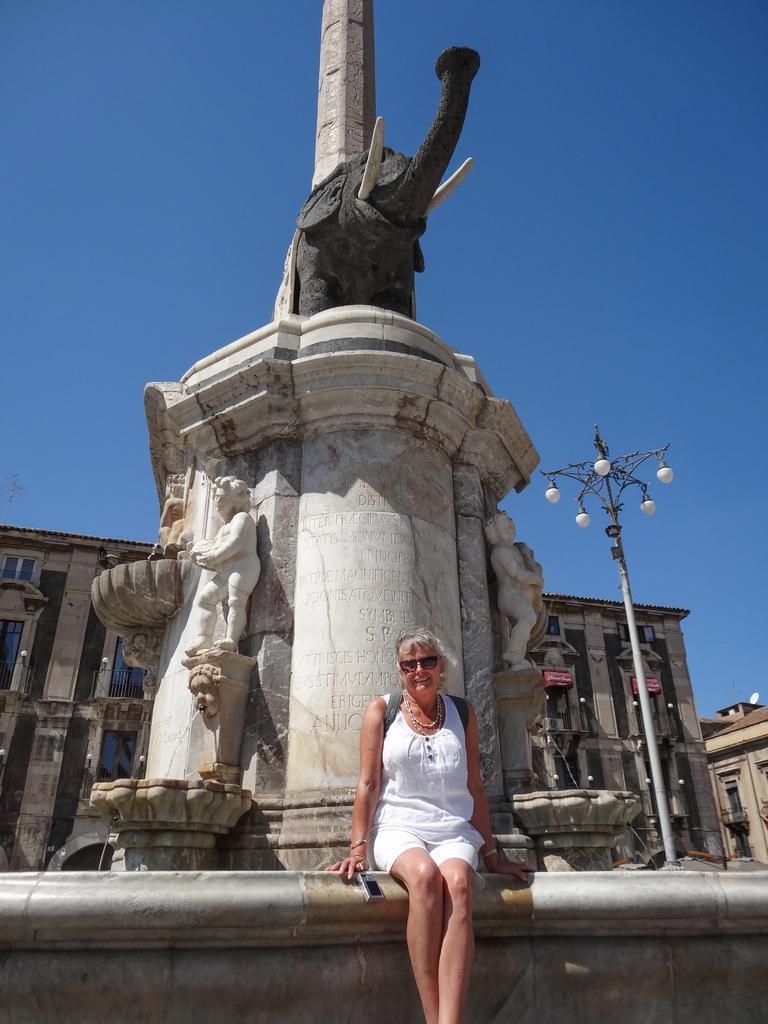Can you describe this image briefly? In this picture there is sculpture in the center of the image and there is a lady who is sitting in the center of the image. 